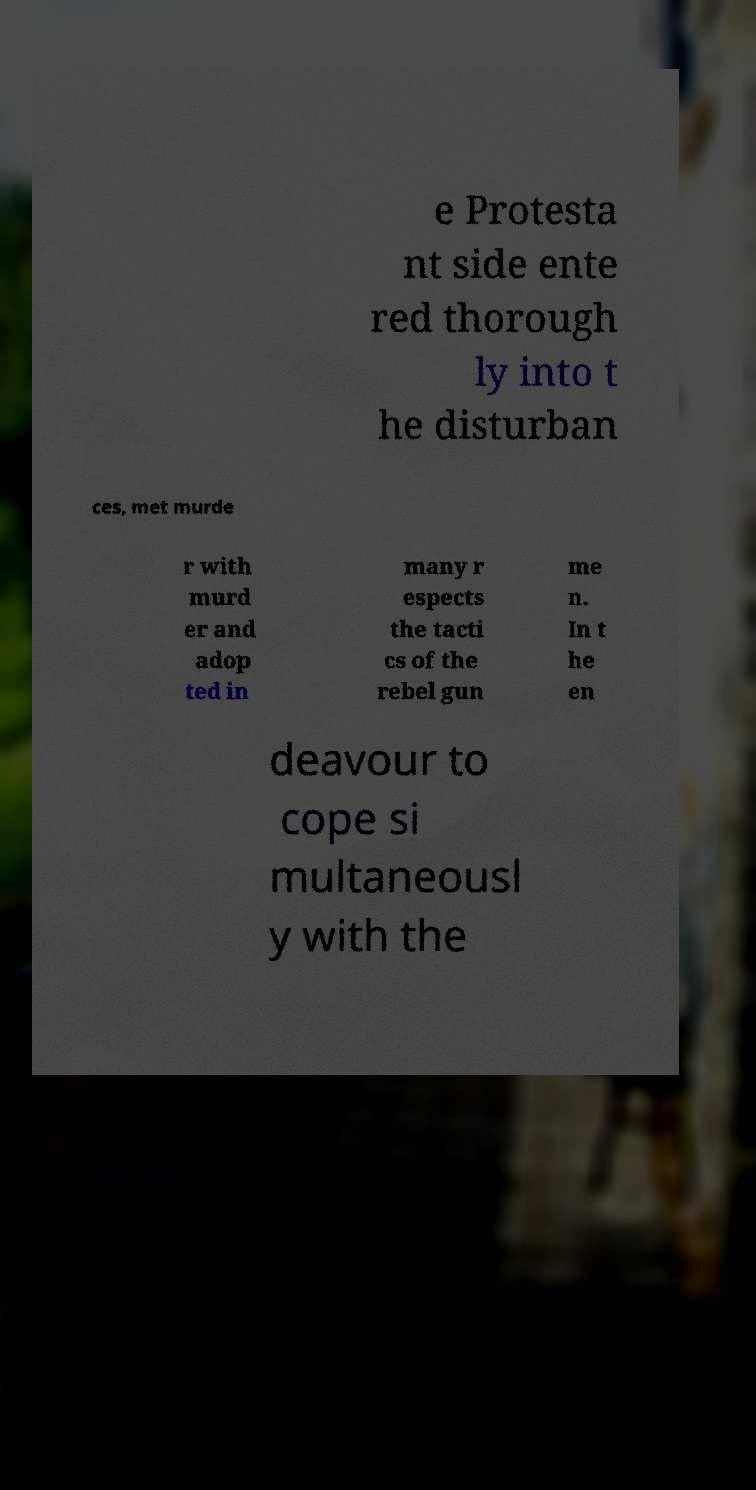Could you extract and type out the text from this image? e Protesta nt side ente red thorough ly into t he disturban ces, met murde r with murd er and adop ted in many r espects the tacti cs of the rebel gun me n. In t he en deavour to cope si multaneousl y with the 